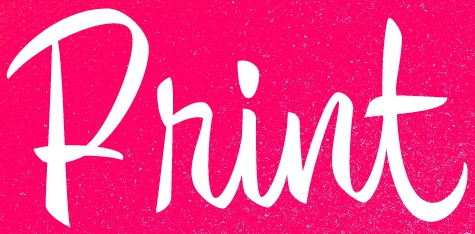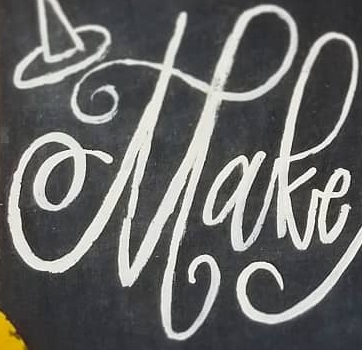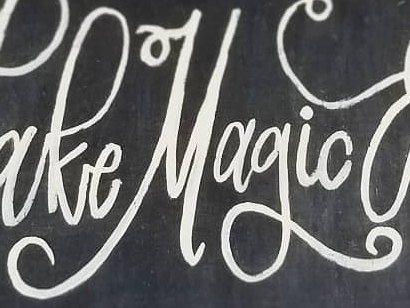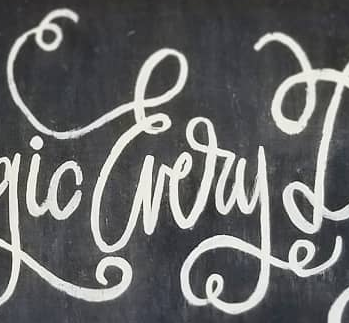What words can you see in these images in sequence, separated by a semicolon? Print; Make; Magic; Every 